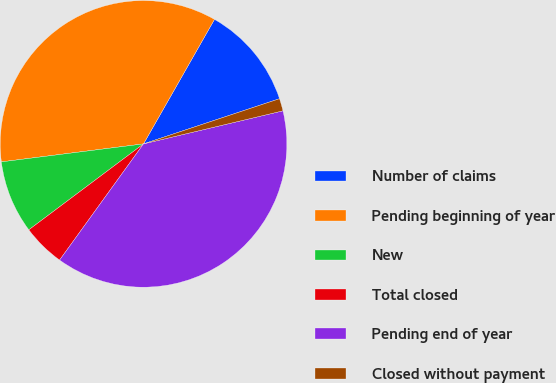Convert chart. <chart><loc_0><loc_0><loc_500><loc_500><pie_chart><fcel>Number of claims<fcel>Pending beginning of year<fcel>New<fcel>Total closed<fcel>Pending end of year<fcel>Closed without payment<nl><fcel>11.65%<fcel>35.25%<fcel>8.23%<fcel>4.81%<fcel>38.66%<fcel>1.4%<nl></chart> 